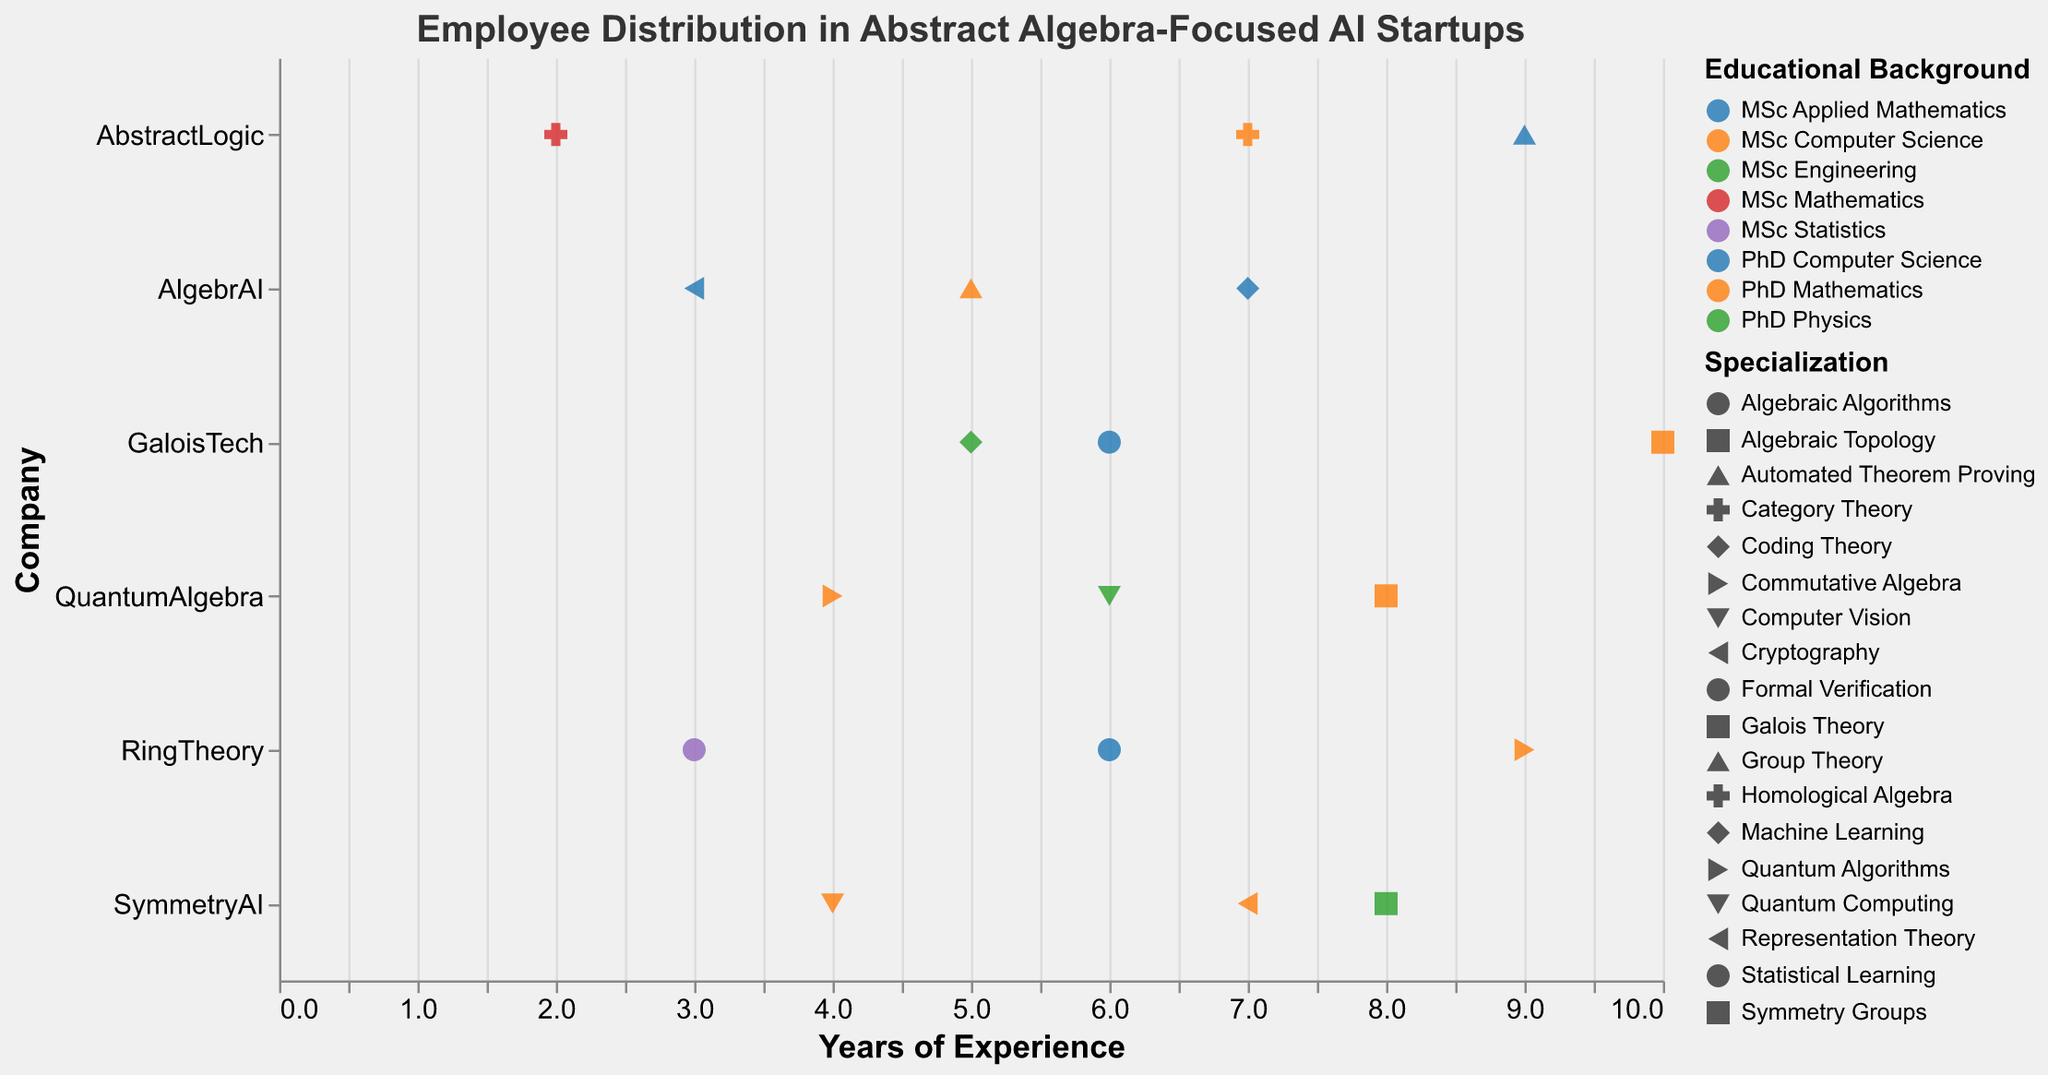what is the title of the plot? The title of the plot is shown at the top in the larger, bold font. It reads "Employee Distribution in Abstract Algebra-Focused AI Startups".
Answer: Employee Distribution in Abstract Algebra-Focused AI Startups Which company has an employee with the highest years of experience, and what is the educational background of that employee? The employee with the highest years of experience is represented by a point farthest to the right along the x-axis. This point corresponds to GaloisTech, and the tooltip reveals that the educational background is "PhD Mathematics".
Answer: GaloisTech, PhD Mathematics How many companies have employees specialized in PhD Physics, and who has the most experienced employee in that category? First, identify the points colored consistently with "PhD Physics" and then count the distinct companies. There are three points, one for each of QuantumAlgebra, SymmetryAI, and another for the most experienced in SymmetryAI's employee with 8 years of experience.
Answer: Three companies, the most experienced is SymmetryAI What is the average years of experience for employees in AbstractLogic? Find all points that align with AbstractLogic on the y-axis and note their years of experience. The years are 9, 7, and 2. The average is calculated as (9+7+2)/3 = 18/3 = 6.
Answer: 6 Compare the median years of experience between PhD Computer Science and PhD Mathematics across all companies. Which one is higher? List the years of experience for each group:
PhD Computer Science: 7, 9, 6, 6
PhD Mathematics: 5, 8, 7, 2, 10, 8, 9
Since both lists effectively need to be sorted and the median is found, comparing 6.5 (on average for even counts) from PhD Computer Science and 8 from Maths makes it evident.
Answer: PhD Mathematics has a higher median Which specialization within GaloisTech has employees with the same years of experience, and how many years are they respectively? Focus on the points along GaloisTech’s y-axis and find any specialization that repeats the experience years. The points show 5 years for MSc Engineering (Coding Theory) and 5 for another MSc Engineering (Coding Theory), indicating the match.
Answer: Coding Theory, 5 years Which company has the most diverse range of specializations and how many do they have? Identify the variety of shapes for each company along the y-axis. AbstractLogic has three unique shapes indicating three specializations: Automated Theorem Proving, Category Theory, and Homological Algebra.
Answer: AbstractLogic, 3 Compare the range of years of experience for MSc employees in AlgebrAI and SymmetryAI. Which company has a broader range? Note years of experiences for MSc in each company:
AlgebrAI: 3 years.
SymmetryAI: 4 years.
The range represents the spread from the minimum to the maximum. AlgebrAI’s range is 0 (3-3), and SymmetryAI’s is 0 (4-4), so neither has a broader range.
Answer: Neither How does the distribution of employees in QuantumAlgebra compare with that in RingTheory by educational background? Observe QuantumAlgebra and RingTheory and note the colors (educational backgrounds). Both companies differ across their PhD and MSc values for Mathematics, Physics, Computer Science, and relate distinctly, but still comparably housing specialization differences.
Answer: They have distinct but similar educational backgrounds 